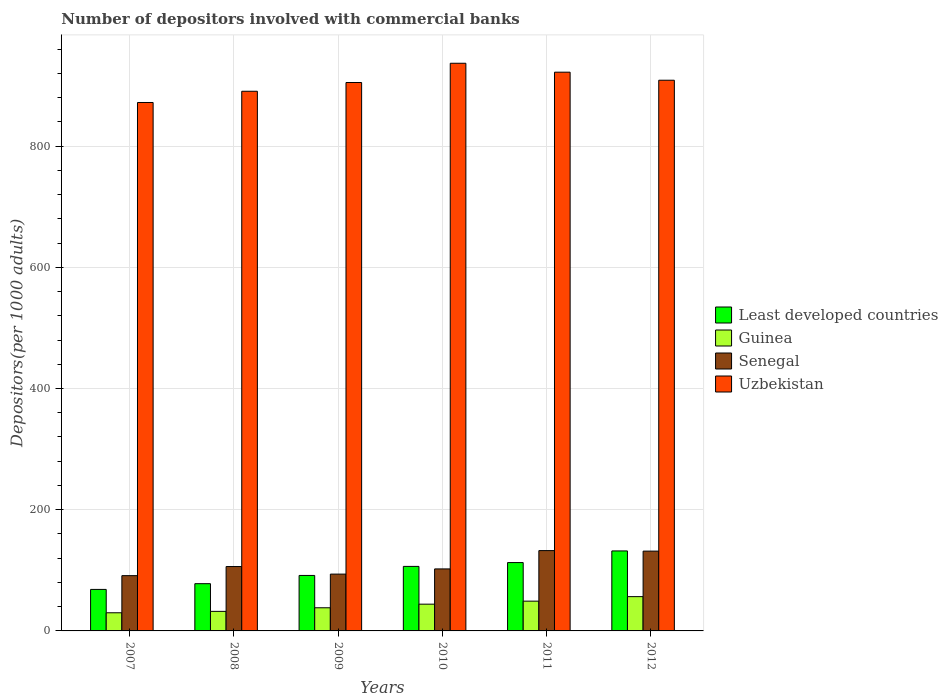How many groups of bars are there?
Provide a succinct answer. 6. Are the number of bars on each tick of the X-axis equal?
Your answer should be compact. Yes. How many bars are there on the 6th tick from the left?
Your response must be concise. 4. How many bars are there on the 2nd tick from the right?
Give a very brief answer. 4. What is the label of the 1st group of bars from the left?
Offer a terse response. 2007. What is the number of depositors involved with commercial banks in Senegal in 2009?
Offer a very short reply. 93.77. Across all years, what is the maximum number of depositors involved with commercial banks in Least developed countries?
Provide a short and direct response. 131.99. Across all years, what is the minimum number of depositors involved with commercial banks in Least developed countries?
Offer a terse response. 68.48. In which year was the number of depositors involved with commercial banks in Senegal minimum?
Provide a short and direct response. 2007. What is the total number of depositors involved with commercial banks in Guinea in the graph?
Your answer should be very brief. 250.28. What is the difference between the number of depositors involved with commercial banks in Senegal in 2010 and that in 2012?
Your answer should be compact. -29.37. What is the difference between the number of depositors involved with commercial banks in Least developed countries in 2008 and the number of depositors involved with commercial banks in Senegal in 2012?
Your answer should be very brief. -53.74. What is the average number of depositors involved with commercial banks in Least developed countries per year?
Your answer should be very brief. 98.21. In the year 2010, what is the difference between the number of depositors involved with commercial banks in Uzbekistan and number of depositors involved with commercial banks in Least developed countries?
Make the answer very short. 830.24. In how many years, is the number of depositors involved with commercial banks in Senegal greater than 680?
Offer a very short reply. 0. What is the ratio of the number of depositors involved with commercial banks in Senegal in 2009 to that in 2010?
Keep it short and to the point. 0.92. What is the difference between the highest and the second highest number of depositors involved with commercial banks in Senegal?
Your answer should be very brief. 0.84. What is the difference between the highest and the lowest number of depositors involved with commercial banks in Senegal?
Keep it short and to the point. 41.33. In how many years, is the number of depositors involved with commercial banks in Senegal greater than the average number of depositors involved with commercial banks in Senegal taken over all years?
Give a very brief answer. 2. Is it the case that in every year, the sum of the number of depositors involved with commercial banks in Guinea and number of depositors involved with commercial banks in Least developed countries is greater than the sum of number of depositors involved with commercial banks in Senegal and number of depositors involved with commercial banks in Uzbekistan?
Your response must be concise. No. What does the 4th bar from the left in 2009 represents?
Offer a very short reply. Uzbekistan. What does the 4th bar from the right in 2010 represents?
Make the answer very short. Least developed countries. Is it the case that in every year, the sum of the number of depositors involved with commercial banks in Least developed countries and number of depositors involved with commercial banks in Senegal is greater than the number of depositors involved with commercial banks in Guinea?
Provide a short and direct response. Yes. How many years are there in the graph?
Ensure brevity in your answer.  6. Are the values on the major ticks of Y-axis written in scientific E-notation?
Your answer should be very brief. No. Does the graph contain grids?
Keep it short and to the point. Yes. Where does the legend appear in the graph?
Provide a succinct answer. Center right. What is the title of the graph?
Provide a succinct answer. Number of depositors involved with commercial banks. Does "Ireland" appear as one of the legend labels in the graph?
Your response must be concise. No. What is the label or title of the X-axis?
Provide a succinct answer. Years. What is the label or title of the Y-axis?
Provide a succinct answer. Depositors(per 1000 adults). What is the Depositors(per 1000 adults) in Least developed countries in 2007?
Offer a terse response. 68.48. What is the Depositors(per 1000 adults) in Guinea in 2007?
Offer a terse response. 29.95. What is the Depositors(per 1000 adults) in Senegal in 2007?
Offer a very short reply. 91.2. What is the Depositors(per 1000 adults) of Uzbekistan in 2007?
Your response must be concise. 871.99. What is the Depositors(per 1000 adults) of Least developed countries in 2008?
Provide a short and direct response. 77.95. What is the Depositors(per 1000 adults) of Guinea in 2008?
Your response must be concise. 32.26. What is the Depositors(per 1000 adults) of Senegal in 2008?
Your answer should be compact. 106.25. What is the Depositors(per 1000 adults) of Uzbekistan in 2008?
Make the answer very short. 890.51. What is the Depositors(per 1000 adults) of Least developed countries in 2009?
Provide a succinct answer. 91.54. What is the Depositors(per 1000 adults) of Guinea in 2009?
Provide a succinct answer. 38.21. What is the Depositors(per 1000 adults) of Senegal in 2009?
Offer a very short reply. 93.77. What is the Depositors(per 1000 adults) in Uzbekistan in 2009?
Offer a terse response. 904.94. What is the Depositors(per 1000 adults) of Least developed countries in 2010?
Your response must be concise. 106.48. What is the Depositors(per 1000 adults) in Guinea in 2010?
Provide a short and direct response. 44.16. What is the Depositors(per 1000 adults) of Senegal in 2010?
Provide a short and direct response. 102.32. What is the Depositors(per 1000 adults) in Uzbekistan in 2010?
Your answer should be compact. 936.72. What is the Depositors(per 1000 adults) of Least developed countries in 2011?
Offer a terse response. 112.8. What is the Depositors(per 1000 adults) in Guinea in 2011?
Your response must be concise. 49.12. What is the Depositors(per 1000 adults) in Senegal in 2011?
Your answer should be very brief. 132.54. What is the Depositors(per 1000 adults) of Uzbekistan in 2011?
Your answer should be very brief. 921.99. What is the Depositors(per 1000 adults) of Least developed countries in 2012?
Keep it short and to the point. 131.99. What is the Depositors(per 1000 adults) of Guinea in 2012?
Your answer should be very brief. 56.59. What is the Depositors(per 1000 adults) of Senegal in 2012?
Your answer should be very brief. 131.69. What is the Depositors(per 1000 adults) in Uzbekistan in 2012?
Make the answer very short. 908.73. Across all years, what is the maximum Depositors(per 1000 adults) in Least developed countries?
Keep it short and to the point. 131.99. Across all years, what is the maximum Depositors(per 1000 adults) of Guinea?
Provide a succinct answer. 56.59. Across all years, what is the maximum Depositors(per 1000 adults) of Senegal?
Ensure brevity in your answer.  132.54. Across all years, what is the maximum Depositors(per 1000 adults) in Uzbekistan?
Your answer should be very brief. 936.72. Across all years, what is the minimum Depositors(per 1000 adults) of Least developed countries?
Provide a succinct answer. 68.48. Across all years, what is the minimum Depositors(per 1000 adults) in Guinea?
Provide a short and direct response. 29.95. Across all years, what is the minimum Depositors(per 1000 adults) in Senegal?
Make the answer very short. 91.2. Across all years, what is the minimum Depositors(per 1000 adults) of Uzbekistan?
Offer a very short reply. 871.99. What is the total Depositors(per 1000 adults) of Least developed countries in the graph?
Provide a short and direct response. 589.24. What is the total Depositors(per 1000 adults) of Guinea in the graph?
Your answer should be compact. 250.28. What is the total Depositors(per 1000 adults) in Senegal in the graph?
Provide a short and direct response. 657.78. What is the total Depositors(per 1000 adults) in Uzbekistan in the graph?
Give a very brief answer. 5434.87. What is the difference between the Depositors(per 1000 adults) in Least developed countries in 2007 and that in 2008?
Make the answer very short. -9.47. What is the difference between the Depositors(per 1000 adults) of Guinea in 2007 and that in 2008?
Keep it short and to the point. -2.31. What is the difference between the Depositors(per 1000 adults) in Senegal in 2007 and that in 2008?
Offer a terse response. -15.04. What is the difference between the Depositors(per 1000 adults) of Uzbekistan in 2007 and that in 2008?
Give a very brief answer. -18.52. What is the difference between the Depositors(per 1000 adults) in Least developed countries in 2007 and that in 2009?
Your answer should be very brief. -23.06. What is the difference between the Depositors(per 1000 adults) in Guinea in 2007 and that in 2009?
Provide a succinct answer. -8.26. What is the difference between the Depositors(per 1000 adults) in Senegal in 2007 and that in 2009?
Keep it short and to the point. -2.56. What is the difference between the Depositors(per 1000 adults) in Uzbekistan in 2007 and that in 2009?
Give a very brief answer. -32.96. What is the difference between the Depositors(per 1000 adults) of Least developed countries in 2007 and that in 2010?
Provide a succinct answer. -38. What is the difference between the Depositors(per 1000 adults) in Guinea in 2007 and that in 2010?
Make the answer very short. -14.21. What is the difference between the Depositors(per 1000 adults) in Senegal in 2007 and that in 2010?
Give a very brief answer. -11.12. What is the difference between the Depositors(per 1000 adults) of Uzbekistan in 2007 and that in 2010?
Ensure brevity in your answer.  -64.73. What is the difference between the Depositors(per 1000 adults) in Least developed countries in 2007 and that in 2011?
Keep it short and to the point. -44.32. What is the difference between the Depositors(per 1000 adults) of Guinea in 2007 and that in 2011?
Offer a very short reply. -19.18. What is the difference between the Depositors(per 1000 adults) in Senegal in 2007 and that in 2011?
Provide a succinct answer. -41.33. What is the difference between the Depositors(per 1000 adults) in Uzbekistan in 2007 and that in 2011?
Your response must be concise. -50. What is the difference between the Depositors(per 1000 adults) of Least developed countries in 2007 and that in 2012?
Offer a very short reply. -63.51. What is the difference between the Depositors(per 1000 adults) of Guinea in 2007 and that in 2012?
Keep it short and to the point. -26.64. What is the difference between the Depositors(per 1000 adults) of Senegal in 2007 and that in 2012?
Your response must be concise. -40.49. What is the difference between the Depositors(per 1000 adults) in Uzbekistan in 2007 and that in 2012?
Ensure brevity in your answer.  -36.74. What is the difference between the Depositors(per 1000 adults) of Least developed countries in 2008 and that in 2009?
Your answer should be compact. -13.59. What is the difference between the Depositors(per 1000 adults) of Guinea in 2008 and that in 2009?
Make the answer very short. -5.95. What is the difference between the Depositors(per 1000 adults) in Senegal in 2008 and that in 2009?
Keep it short and to the point. 12.48. What is the difference between the Depositors(per 1000 adults) in Uzbekistan in 2008 and that in 2009?
Keep it short and to the point. -14.44. What is the difference between the Depositors(per 1000 adults) in Least developed countries in 2008 and that in 2010?
Offer a terse response. -28.53. What is the difference between the Depositors(per 1000 adults) of Guinea in 2008 and that in 2010?
Make the answer very short. -11.9. What is the difference between the Depositors(per 1000 adults) of Senegal in 2008 and that in 2010?
Offer a very short reply. 3.92. What is the difference between the Depositors(per 1000 adults) in Uzbekistan in 2008 and that in 2010?
Provide a succinct answer. -46.21. What is the difference between the Depositors(per 1000 adults) in Least developed countries in 2008 and that in 2011?
Ensure brevity in your answer.  -34.85. What is the difference between the Depositors(per 1000 adults) of Guinea in 2008 and that in 2011?
Give a very brief answer. -16.87. What is the difference between the Depositors(per 1000 adults) of Senegal in 2008 and that in 2011?
Offer a very short reply. -26.29. What is the difference between the Depositors(per 1000 adults) in Uzbekistan in 2008 and that in 2011?
Your response must be concise. -31.48. What is the difference between the Depositors(per 1000 adults) of Least developed countries in 2008 and that in 2012?
Your answer should be very brief. -54.04. What is the difference between the Depositors(per 1000 adults) of Guinea in 2008 and that in 2012?
Give a very brief answer. -24.33. What is the difference between the Depositors(per 1000 adults) in Senegal in 2008 and that in 2012?
Your answer should be very brief. -25.45. What is the difference between the Depositors(per 1000 adults) in Uzbekistan in 2008 and that in 2012?
Keep it short and to the point. -18.22. What is the difference between the Depositors(per 1000 adults) of Least developed countries in 2009 and that in 2010?
Provide a short and direct response. -14.94. What is the difference between the Depositors(per 1000 adults) of Guinea in 2009 and that in 2010?
Provide a succinct answer. -5.95. What is the difference between the Depositors(per 1000 adults) of Senegal in 2009 and that in 2010?
Offer a terse response. -8.56. What is the difference between the Depositors(per 1000 adults) of Uzbekistan in 2009 and that in 2010?
Provide a short and direct response. -31.77. What is the difference between the Depositors(per 1000 adults) in Least developed countries in 2009 and that in 2011?
Make the answer very short. -21.26. What is the difference between the Depositors(per 1000 adults) in Guinea in 2009 and that in 2011?
Your answer should be very brief. -10.92. What is the difference between the Depositors(per 1000 adults) of Senegal in 2009 and that in 2011?
Your answer should be very brief. -38.77. What is the difference between the Depositors(per 1000 adults) of Uzbekistan in 2009 and that in 2011?
Keep it short and to the point. -17.04. What is the difference between the Depositors(per 1000 adults) in Least developed countries in 2009 and that in 2012?
Make the answer very short. -40.44. What is the difference between the Depositors(per 1000 adults) in Guinea in 2009 and that in 2012?
Your answer should be very brief. -18.38. What is the difference between the Depositors(per 1000 adults) in Senegal in 2009 and that in 2012?
Your answer should be compact. -37.92. What is the difference between the Depositors(per 1000 adults) of Uzbekistan in 2009 and that in 2012?
Your response must be concise. -3.78. What is the difference between the Depositors(per 1000 adults) in Least developed countries in 2010 and that in 2011?
Provide a succinct answer. -6.32. What is the difference between the Depositors(per 1000 adults) of Guinea in 2010 and that in 2011?
Give a very brief answer. -4.97. What is the difference between the Depositors(per 1000 adults) of Senegal in 2010 and that in 2011?
Keep it short and to the point. -30.21. What is the difference between the Depositors(per 1000 adults) in Uzbekistan in 2010 and that in 2011?
Your response must be concise. 14.73. What is the difference between the Depositors(per 1000 adults) of Least developed countries in 2010 and that in 2012?
Provide a succinct answer. -25.51. What is the difference between the Depositors(per 1000 adults) in Guinea in 2010 and that in 2012?
Your answer should be very brief. -12.44. What is the difference between the Depositors(per 1000 adults) in Senegal in 2010 and that in 2012?
Your answer should be very brief. -29.37. What is the difference between the Depositors(per 1000 adults) in Uzbekistan in 2010 and that in 2012?
Ensure brevity in your answer.  27.99. What is the difference between the Depositors(per 1000 adults) in Least developed countries in 2011 and that in 2012?
Offer a terse response. -19.19. What is the difference between the Depositors(per 1000 adults) in Guinea in 2011 and that in 2012?
Your answer should be very brief. -7.47. What is the difference between the Depositors(per 1000 adults) in Senegal in 2011 and that in 2012?
Your response must be concise. 0.84. What is the difference between the Depositors(per 1000 adults) in Uzbekistan in 2011 and that in 2012?
Your answer should be compact. 13.26. What is the difference between the Depositors(per 1000 adults) in Least developed countries in 2007 and the Depositors(per 1000 adults) in Guinea in 2008?
Offer a terse response. 36.22. What is the difference between the Depositors(per 1000 adults) of Least developed countries in 2007 and the Depositors(per 1000 adults) of Senegal in 2008?
Your answer should be very brief. -37.77. What is the difference between the Depositors(per 1000 adults) of Least developed countries in 2007 and the Depositors(per 1000 adults) of Uzbekistan in 2008?
Your answer should be compact. -822.02. What is the difference between the Depositors(per 1000 adults) in Guinea in 2007 and the Depositors(per 1000 adults) in Senegal in 2008?
Keep it short and to the point. -76.3. What is the difference between the Depositors(per 1000 adults) in Guinea in 2007 and the Depositors(per 1000 adults) in Uzbekistan in 2008?
Your response must be concise. -860.56. What is the difference between the Depositors(per 1000 adults) of Senegal in 2007 and the Depositors(per 1000 adults) of Uzbekistan in 2008?
Offer a terse response. -799.3. What is the difference between the Depositors(per 1000 adults) in Least developed countries in 2007 and the Depositors(per 1000 adults) in Guinea in 2009?
Offer a very short reply. 30.27. What is the difference between the Depositors(per 1000 adults) of Least developed countries in 2007 and the Depositors(per 1000 adults) of Senegal in 2009?
Keep it short and to the point. -25.29. What is the difference between the Depositors(per 1000 adults) of Least developed countries in 2007 and the Depositors(per 1000 adults) of Uzbekistan in 2009?
Offer a very short reply. -836.46. What is the difference between the Depositors(per 1000 adults) in Guinea in 2007 and the Depositors(per 1000 adults) in Senegal in 2009?
Keep it short and to the point. -63.82. What is the difference between the Depositors(per 1000 adults) of Guinea in 2007 and the Depositors(per 1000 adults) of Uzbekistan in 2009?
Provide a succinct answer. -875. What is the difference between the Depositors(per 1000 adults) in Senegal in 2007 and the Depositors(per 1000 adults) in Uzbekistan in 2009?
Provide a succinct answer. -813.74. What is the difference between the Depositors(per 1000 adults) of Least developed countries in 2007 and the Depositors(per 1000 adults) of Guinea in 2010?
Offer a very short reply. 24.33. What is the difference between the Depositors(per 1000 adults) in Least developed countries in 2007 and the Depositors(per 1000 adults) in Senegal in 2010?
Your answer should be compact. -33.84. What is the difference between the Depositors(per 1000 adults) in Least developed countries in 2007 and the Depositors(per 1000 adults) in Uzbekistan in 2010?
Provide a succinct answer. -868.24. What is the difference between the Depositors(per 1000 adults) in Guinea in 2007 and the Depositors(per 1000 adults) in Senegal in 2010?
Keep it short and to the point. -72.38. What is the difference between the Depositors(per 1000 adults) of Guinea in 2007 and the Depositors(per 1000 adults) of Uzbekistan in 2010?
Provide a short and direct response. -906.77. What is the difference between the Depositors(per 1000 adults) of Senegal in 2007 and the Depositors(per 1000 adults) of Uzbekistan in 2010?
Offer a very short reply. -845.51. What is the difference between the Depositors(per 1000 adults) of Least developed countries in 2007 and the Depositors(per 1000 adults) of Guinea in 2011?
Your answer should be very brief. 19.36. What is the difference between the Depositors(per 1000 adults) of Least developed countries in 2007 and the Depositors(per 1000 adults) of Senegal in 2011?
Offer a very short reply. -64.06. What is the difference between the Depositors(per 1000 adults) of Least developed countries in 2007 and the Depositors(per 1000 adults) of Uzbekistan in 2011?
Offer a very short reply. -853.51. What is the difference between the Depositors(per 1000 adults) of Guinea in 2007 and the Depositors(per 1000 adults) of Senegal in 2011?
Offer a terse response. -102.59. What is the difference between the Depositors(per 1000 adults) in Guinea in 2007 and the Depositors(per 1000 adults) in Uzbekistan in 2011?
Give a very brief answer. -892.04. What is the difference between the Depositors(per 1000 adults) of Senegal in 2007 and the Depositors(per 1000 adults) of Uzbekistan in 2011?
Your answer should be compact. -830.78. What is the difference between the Depositors(per 1000 adults) of Least developed countries in 2007 and the Depositors(per 1000 adults) of Guinea in 2012?
Your answer should be compact. 11.89. What is the difference between the Depositors(per 1000 adults) in Least developed countries in 2007 and the Depositors(per 1000 adults) in Senegal in 2012?
Make the answer very short. -63.21. What is the difference between the Depositors(per 1000 adults) of Least developed countries in 2007 and the Depositors(per 1000 adults) of Uzbekistan in 2012?
Provide a succinct answer. -840.25. What is the difference between the Depositors(per 1000 adults) in Guinea in 2007 and the Depositors(per 1000 adults) in Senegal in 2012?
Provide a short and direct response. -101.75. What is the difference between the Depositors(per 1000 adults) in Guinea in 2007 and the Depositors(per 1000 adults) in Uzbekistan in 2012?
Provide a succinct answer. -878.78. What is the difference between the Depositors(per 1000 adults) of Senegal in 2007 and the Depositors(per 1000 adults) of Uzbekistan in 2012?
Offer a terse response. -817.52. What is the difference between the Depositors(per 1000 adults) in Least developed countries in 2008 and the Depositors(per 1000 adults) in Guinea in 2009?
Provide a succinct answer. 39.74. What is the difference between the Depositors(per 1000 adults) in Least developed countries in 2008 and the Depositors(per 1000 adults) in Senegal in 2009?
Keep it short and to the point. -15.82. What is the difference between the Depositors(per 1000 adults) in Least developed countries in 2008 and the Depositors(per 1000 adults) in Uzbekistan in 2009?
Ensure brevity in your answer.  -826.99. What is the difference between the Depositors(per 1000 adults) in Guinea in 2008 and the Depositors(per 1000 adults) in Senegal in 2009?
Ensure brevity in your answer.  -61.51. What is the difference between the Depositors(per 1000 adults) in Guinea in 2008 and the Depositors(per 1000 adults) in Uzbekistan in 2009?
Your response must be concise. -872.69. What is the difference between the Depositors(per 1000 adults) in Senegal in 2008 and the Depositors(per 1000 adults) in Uzbekistan in 2009?
Give a very brief answer. -798.7. What is the difference between the Depositors(per 1000 adults) in Least developed countries in 2008 and the Depositors(per 1000 adults) in Guinea in 2010?
Provide a short and direct response. 33.8. What is the difference between the Depositors(per 1000 adults) in Least developed countries in 2008 and the Depositors(per 1000 adults) in Senegal in 2010?
Your response must be concise. -24.37. What is the difference between the Depositors(per 1000 adults) in Least developed countries in 2008 and the Depositors(per 1000 adults) in Uzbekistan in 2010?
Your response must be concise. -858.77. What is the difference between the Depositors(per 1000 adults) in Guinea in 2008 and the Depositors(per 1000 adults) in Senegal in 2010?
Offer a very short reply. -70.07. What is the difference between the Depositors(per 1000 adults) in Guinea in 2008 and the Depositors(per 1000 adults) in Uzbekistan in 2010?
Ensure brevity in your answer.  -904.46. What is the difference between the Depositors(per 1000 adults) of Senegal in 2008 and the Depositors(per 1000 adults) of Uzbekistan in 2010?
Provide a short and direct response. -830.47. What is the difference between the Depositors(per 1000 adults) in Least developed countries in 2008 and the Depositors(per 1000 adults) in Guinea in 2011?
Provide a succinct answer. 28.83. What is the difference between the Depositors(per 1000 adults) in Least developed countries in 2008 and the Depositors(per 1000 adults) in Senegal in 2011?
Your response must be concise. -54.59. What is the difference between the Depositors(per 1000 adults) of Least developed countries in 2008 and the Depositors(per 1000 adults) of Uzbekistan in 2011?
Your response must be concise. -844.04. What is the difference between the Depositors(per 1000 adults) in Guinea in 2008 and the Depositors(per 1000 adults) in Senegal in 2011?
Offer a very short reply. -100.28. What is the difference between the Depositors(per 1000 adults) of Guinea in 2008 and the Depositors(per 1000 adults) of Uzbekistan in 2011?
Offer a terse response. -889.73. What is the difference between the Depositors(per 1000 adults) in Senegal in 2008 and the Depositors(per 1000 adults) in Uzbekistan in 2011?
Your answer should be very brief. -815.74. What is the difference between the Depositors(per 1000 adults) in Least developed countries in 2008 and the Depositors(per 1000 adults) in Guinea in 2012?
Provide a succinct answer. 21.36. What is the difference between the Depositors(per 1000 adults) of Least developed countries in 2008 and the Depositors(per 1000 adults) of Senegal in 2012?
Ensure brevity in your answer.  -53.74. What is the difference between the Depositors(per 1000 adults) in Least developed countries in 2008 and the Depositors(per 1000 adults) in Uzbekistan in 2012?
Provide a short and direct response. -830.78. What is the difference between the Depositors(per 1000 adults) of Guinea in 2008 and the Depositors(per 1000 adults) of Senegal in 2012?
Make the answer very short. -99.44. What is the difference between the Depositors(per 1000 adults) in Guinea in 2008 and the Depositors(per 1000 adults) in Uzbekistan in 2012?
Offer a terse response. -876.47. What is the difference between the Depositors(per 1000 adults) of Senegal in 2008 and the Depositors(per 1000 adults) of Uzbekistan in 2012?
Offer a very short reply. -802.48. What is the difference between the Depositors(per 1000 adults) of Least developed countries in 2009 and the Depositors(per 1000 adults) of Guinea in 2010?
Ensure brevity in your answer.  47.39. What is the difference between the Depositors(per 1000 adults) in Least developed countries in 2009 and the Depositors(per 1000 adults) in Senegal in 2010?
Keep it short and to the point. -10.78. What is the difference between the Depositors(per 1000 adults) in Least developed countries in 2009 and the Depositors(per 1000 adults) in Uzbekistan in 2010?
Your answer should be compact. -845.17. What is the difference between the Depositors(per 1000 adults) in Guinea in 2009 and the Depositors(per 1000 adults) in Senegal in 2010?
Provide a succinct answer. -64.12. What is the difference between the Depositors(per 1000 adults) in Guinea in 2009 and the Depositors(per 1000 adults) in Uzbekistan in 2010?
Your answer should be compact. -898.51. What is the difference between the Depositors(per 1000 adults) of Senegal in 2009 and the Depositors(per 1000 adults) of Uzbekistan in 2010?
Keep it short and to the point. -842.95. What is the difference between the Depositors(per 1000 adults) in Least developed countries in 2009 and the Depositors(per 1000 adults) in Guinea in 2011?
Your answer should be compact. 42.42. What is the difference between the Depositors(per 1000 adults) of Least developed countries in 2009 and the Depositors(per 1000 adults) of Senegal in 2011?
Your response must be concise. -40.99. What is the difference between the Depositors(per 1000 adults) of Least developed countries in 2009 and the Depositors(per 1000 adults) of Uzbekistan in 2011?
Your response must be concise. -830.44. What is the difference between the Depositors(per 1000 adults) of Guinea in 2009 and the Depositors(per 1000 adults) of Senegal in 2011?
Give a very brief answer. -94.33. What is the difference between the Depositors(per 1000 adults) in Guinea in 2009 and the Depositors(per 1000 adults) in Uzbekistan in 2011?
Offer a terse response. -883.78. What is the difference between the Depositors(per 1000 adults) of Senegal in 2009 and the Depositors(per 1000 adults) of Uzbekistan in 2011?
Your answer should be compact. -828.22. What is the difference between the Depositors(per 1000 adults) in Least developed countries in 2009 and the Depositors(per 1000 adults) in Guinea in 2012?
Provide a short and direct response. 34.95. What is the difference between the Depositors(per 1000 adults) in Least developed countries in 2009 and the Depositors(per 1000 adults) in Senegal in 2012?
Offer a very short reply. -40.15. What is the difference between the Depositors(per 1000 adults) in Least developed countries in 2009 and the Depositors(per 1000 adults) in Uzbekistan in 2012?
Provide a short and direct response. -817.18. What is the difference between the Depositors(per 1000 adults) of Guinea in 2009 and the Depositors(per 1000 adults) of Senegal in 2012?
Keep it short and to the point. -93.49. What is the difference between the Depositors(per 1000 adults) in Guinea in 2009 and the Depositors(per 1000 adults) in Uzbekistan in 2012?
Provide a succinct answer. -870.52. What is the difference between the Depositors(per 1000 adults) in Senegal in 2009 and the Depositors(per 1000 adults) in Uzbekistan in 2012?
Provide a succinct answer. -814.96. What is the difference between the Depositors(per 1000 adults) of Least developed countries in 2010 and the Depositors(per 1000 adults) of Guinea in 2011?
Provide a short and direct response. 57.36. What is the difference between the Depositors(per 1000 adults) of Least developed countries in 2010 and the Depositors(per 1000 adults) of Senegal in 2011?
Ensure brevity in your answer.  -26.05. What is the difference between the Depositors(per 1000 adults) of Least developed countries in 2010 and the Depositors(per 1000 adults) of Uzbekistan in 2011?
Give a very brief answer. -815.51. What is the difference between the Depositors(per 1000 adults) of Guinea in 2010 and the Depositors(per 1000 adults) of Senegal in 2011?
Keep it short and to the point. -88.38. What is the difference between the Depositors(per 1000 adults) of Guinea in 2010 and the Depositors(per 1000 adults) of Uzbekistan in 2011?
Offer a very short reply. -877.83. What is the difference between the Depositors(per 1000 adults) of Senegal in 2010 and the Depositors(per 1000 adults) of Uzbekistan in 2011?
Your answer should be very brief. -819.66. What is the difference between the Depositors(per 1000 adults) in Least developed countries in 2010 and the Depositors(per 1000 adults) in Guinea in 2012?
Provide a succinct answer. 49.89. What is the difference between the Depositors(per 1000 adults) in Least developed countries in 2010 and the Depositors(per 1000 adults) in Senegal in 2012?
Offer a very short reply. -25.21. What is the difference between the Depositors(per 1000 adults) of Least developed countries in 2010 and the Depositors(per 1000 adults) of Uzbekistan in 2012?
Your response must be concise. -802.25. What is the difference between the Depositors(per 1000 adults) of Guinea in 2010 and the Depositors(per 1000 adults) of Senegal in 2012?
Your answer should be very brief. -87.54. What is the difference between the Depositors(per 1000 adults) in Guinea in 2010 and the Depositors(per 1000 adults) in Uzbekistan in 2012?
Make the answer very short. -864.57. What is the difference between the Depositors(per 1000 adults) of Senegal in 2010 and the Depositors(per 1000 adults) of Uzbekistan in 2012?
Keep it short and to the point. -806.4. What is the difference between the Depositors(per 1000 adults) in Least developed countries in 2011 and the Depositors(per 1000 adults) in Guinea in 2012?
Offer a very short reply. 56.21. What is the difference between the Depositors(per 1000 adults) in Least developed countries in 2011 and the Depositors(per 1000 adults) in Senegal in 2012?
Give a very brief answer. -18.89. What is the difference between the Depositors(per 1000 adults) of Least developed countries in 2011 and the Depositors(per 1000 adults) of Uzbekistan in 2012?
Your answer should be very brief. -795.93. What is the difference between the Depositors(per 1000 adults) in Guinea in 2011 and the Depositors(per 1000 adults) in Senegal in 2012?
Ensure brevity in your answer.  -82.57. What is the difference between the Depositors(per 1000 adults) in Guinea in 2011 and the Depositors(per 1000 adults) in Uzbekistan in 2012?
Your response must be concise. -859.6. What is the difference between the Depositors(per 1000 adults) of Senegal in 2011 and the Depositors(per 1000 adults) of Uzbekistan in 2012?
Keep it short and to the point. -776.19. What is the average Depositors(per 1000 adults) in Least developed countries per year?
Keep it short and to the point. 98.21. What is the average Depositors(per 1000 adults) of Guinea per year?
Offer a very short reply. 41.71. What is the average Depositors(per 1000 adults) of Senegal per year?
Keep it short and to the point. 109.63. What is the average Depositors(per 1000 adults) in Uzbekistan per year?
Your response must be concise. 905.81. In the year 2007, what is the difference between the Depositors(per 1000 adults) in Least developed countries and Depositors(per 1000 adults) in Guinea?
Offer a very short reply. 38.54. In the year 2007, what is the difference between the Depositors(per 1000 adults) of Least developed countries and Depositors(per 1000 adults) of Senegal?
Give a very brief answer. -22.72. In the year 2007, what is the difference between the Depositors(per 1000 adults) in Least developed countries and Depositors(per 1000 adults) in Uzbekistan?
Keep it short and to the point. -803.51. In the year 2007, what is the difference between the Depositors(per 1000 adults) in Guinea and Depositors(per 1000 adults) in Senegal?
Ensure brevity in your answer.  -61.26. In the year 2007, what is the difference between the Depositors(per 1000 adults) of Guinea and Depositors(per 1000 adults) of Uzbekistan?
Provide a succinct answer. -842.04. In the year 2007, what is the difference between the Depositors(per 1000 adults) in Senegal and Depositors(per 1000 adults) in Uzbekistan?
Keep it short and to the point. -780.78. In the year 2008, what is the difference between the Depositors(per 1000 adults) of Least developed countries and Depositors(per 1000 adults) of Guinea?
Your response must be concise. 45.7. In the year 2008, what is the difference between the Depositors(per 1000 adults) in Least developed countries and Depositors(per 1000 adults) in Senegal?
Give a very brief answer. -28.3. In the year 2008, what is the difference between the Depositors(per 1000 adults) in Least developed countries and Depositors(per 1000 adults) in Uzbekistan?
Offer a very short reply. -812.55. In the year 2008, what is the difference between the Depositors(per 1000 adults) in Guinea and Depositors(per 1000 adults) in Senegal?
Make the answer very short. -73.99. In the year 2008, what is the difference between the Depositors(per 1000 adults) in Guinea and Depositors(per 1000 adults) in Uzbekistan?
Your response must be concise. -858.25. In the year 2008, what is the difference between the Depositors(per 1000 adults) in Senegal and Depositors(per 1000 adults) in Uzbekistan?
Provide a short and direct response. -784.26. In the year 2009, what is the difference between the Depositors(per 1000 adults) of Least developed countries and Depositors(per 1000 adults) of Guinea?
Ensure brevity in your answer.  53.33. In the year 2009, what is the difference between the Depositors(per 1000 adults) in Least developed countries and Depositors(per 1000 adults) in Senegal?
Your answer should be compact. -2.23. In the year 2009, what is the difference between the Depositors(per 1000 adults) in Least developed countries and Depositors(per 1000 adults) in Uzbekistan?
Provide a short and direct response. -813.4. In the year 2009, what is the difference between the Depositors(per 1000 adults) of Guinea and Depositors(per 1000 adults) of Senegal?
Your answer should be compact. -55.56. In the year 2009, what is the difference between the Depositors(per 1000 adults) in Guinea and Depositors(per 1000 adults) in Uzbekistan?
Offer a terse response. -866.73. In the year 2009, what is the difference between the Depositors(per 1000 adults) of Senegal and Depositors(per 1000 adults) of Uzbekistan?
Give a very brief answer. -811.17. In the year 2010, what is the difference between the Depositors(per 1000 adults) of Least developed countries and Depositors(per 1000 adults) of Guinea?
Offer a terse response. 62.33. In the year 2010, what is the difference between the Depositors(per 1000 adults) of Least developed countries and Depositors(per 1000 adults) of Senegal?
Offer a very short reply. 4.16. In the year 2010, what is the difference between the Depositors(per 1000 adults) in Least developed countries and Depositors(per 1000 adults) in Uzbekistan?
Your answer should be very brief. -830.24. In the year 2010, what is the difference between the Depositors(per 1000 adults) of Guinea and Depositors(per 1000 adults) of Senegal?
Keep it short and to the point. -58.17. In the year 2010, what is the difference between the Depositors(per 1000 adults) of Guinea and Depositors(per 1000 adults) of Uzbekistan?
Your answer should be compact. -892.56. In the year 2010, what is the difference between the Depositors(per 1000 adults) of Senegal and Depositors(per 1000 adults) of Uzbekistan?
Offer a terse response. -834.39. In the year 2011, what is the difference between the Depositors(per 1000 adults) of Least developed countries and Depositors(per 1000 adults) of Guinea?
Your answer should be compact. 63.68. In the year 2011, what is the difference between the Depositors(per 1000 adults) in Least developed countries and Depositors(per 1000 adults) in Senegal?
Give a very brief answer. -19.74. In the year 2011, what is the difference between the Depositors(per 1000 adults) in Least developed countries and Depositors(per 1000 adults) in Uzbekistan?
Provide a short and direct response. -809.19. In the year 2011, what is the difference between the Depositors(per 1000 adults) in Guinea and Depositors(per 1000 adults) in Senegal?
Keep it short and to the point. -83.41. In the year 2011, what is the difference between the Depositors(per 1000 adults) of Guinea and Depositors(per 1000 adults) of Uzbekistan?
Make the answer very short. -872.86. In the year 2011, what is the difference between the Depositors(per 1000 adults) of Senegal and Depositors(per 1000 adults) of Uzbekistan?
Ensure brevity in your answer.  -789.45. In the year 2012, what is the difference between the Depositors(per 1000 adults) of Least developed countries and Depositors(per 1000 adults) of Guinea?
Your answer should be very brief. 75.4. In the year 2012, what is the difference between the Depositors(per 1000 adults) in Least developed countries and Depositors(per 1000 adults) in Senegal?
Ensure brevity in your answer.  0.29. In the year 2012, what is the difference between the Depositors(per 1000 adults) in Least developed countries and Depositors(per 1000 adults) in Uzbekistan?
Offer a very short reply. -776.74. In the year 2012, what is the difference between the Depositors(per 1000 adults) of Guinea and Depositors(per 1000 adults) of Senegal?
Make the answer very short. -75.1. In the year 2012, what is the difference between the Depositors(per 1000 adults) in Guinea and Depositors(per 1000 adults) in Uzbekistan?
Ensure brevity in your answer.  -852.14. In the year 2012, what is the difference between the Depositors(per 1000 adults) in Senegal and Depositors(per 1000 adults) in Uzbekistan?
Your answer should be very brief. -777.03. What is the ratio of the Depositors(per 1000 adults) of Least developed countries in 2007 to that in 2008?
Give a very brief answer. 0.88. What is the ratio of the Depositors(per 1000 adults) of Guinea in 2007 to that in 2008?
Give a very brief answer. 0.93. What is the ratio of the Depositors(per 1000 adults) in Senegal in 2007 to that in 2008?
Give a very brief answer. 0.86. What is the ratio of the Depositors(per 1000 adults) of Uzbekistan in 2007 to that in 2008?
Your response must be concise. 0.98. What is the ratio of the Depositors(per 1000 adults) of Least developed countries in 2007 to that in 2009?
Provide a succinct answer. 0.75. What is the ratio of the Depositors(per 1000 adults) in Guinea in 2007 to that in 2009?
Give a very brief answer. 0.78. What is the ratio of the Depositors(per 1000 adults) in Senegal in 2007 to that in 2009?
Keep it short and to the point. 0.97. What is the ratio of the Depositors(per 1000 adults) in Uzbekistan in 2007 to that in 2009?
Keep it short and to the point. 0.96. What is the ratio of the Depositors(per 1000 adults) in Least developed countries in 2007 to that in 2010?
Offer a terse response. 0.64. What is the ratio of the Depositors(per 1000 adults) in Guinea in 2007 to that in 2010?
Your answer should be compact. 0.68. What is the ratio of the Depositors(per 1000 adults) in Senegal in 2007 to that in 2010?
Make the answer very short. 0.89. What is the ratio of the Depositors(per 1000 adults) of Uzbekistan in 2007 to that in 2010?
Keep it short and to the point. 0.93. What is the ratio of the Depositors(per 1000 adults) of Least developed countries in 2007 to that in 2011?
Offer a very short reply. 0.61. What is the ratio of the Depositors(per 1000 adults) of Guinea in 2007 to that in 2011?
Keep it short and to the point. 0.61. What is the ratio of the Depositors(per 1000 adults) in Senegal in 2007 to that in 2011?
Offer a very short reply. 0.69. What is the ratio of the Depositors(per 1000 adults) of Uzbekistan in 2007 to that in 2011?
Your response must be concise. 0.95. What is the ratio of the Depositors(per 1000 adults) in Least developed countries in 2007 to that in 2012?
Your response must be concise. 0.52. What is the ratio of the Depositors(per 1000 adults) in Guinea in 2007 to that in 2012?
Provide a succinct answer. 0.53. What is the ratio of the Depositors(per 1000 adults) in Senegal in 2007 to that in 2012?
Provide a short and direct response. 0.69. What is the ratio of the Depositors(per 1000 adults) in Uzbekistan in 2007 to that in 2012?
Make the answer very short. 0.96. What is the ratio of the Depositors(per 1000 adults) in Least developed countries in 2008 to that in 2009?
Ensure brevity in your answer.  0.85. What is the ratio of the Depositors(per 1000 adults) in Guinea in 2008 to that in 2009?
Ensure brevity in your answer.  0.84. What is the ratio of the Depositors(per 1000 adults) in Senegal in 2008 to that in 2009?
Offer a terse response. 1.13. What is the ratio of the Depositors(per 1000 adults) of Least developed countries in 2008 to that in 2010?
Ensure brevity in your answer.  0.73. What is the ratio of the Depositors(per 1000 adults) of Guinea in 2008 to that in 2010?
Your response must be concise. 0.73. What is the ratio of the Depositors(per 1000 adults) in Senegal in 2008 to that in 2010?
Offer a terse response. 1.04. What is the ratio of the Depositors(per 1000 adults) of Uzbekistan in 2008 to that in 2010?
Ensure brevity in your answer.  0.95. What is the ratio of the Depositors(per 1000 adults) in Least developed countries in 2008 to that in 2011?
Provide a short and direct response. 0.69. What is the ratio of the Depositors(per 1000 adults) of Guinea in 2008 to that in 2011?
Offer a very short reply. 0.66. What is the ratio of the Depositors(per 1000 adults) of Senegal in 2008 to that in 2011?
Your response must be concise. 0.8. What is the ratio of the Depositors(per 1000 adults) of Uzbekistan in 2008 to that in 2011?
Ensure brevity in your answer.  0.97. What is the ratio of the Depositors(per 1000 adults) of Least developed countries in 2008 to that in 2012?
Your answer should be very brief. 0.59. What is the ratio of the Depositors(per 1000 adults) of Guinea in 2008 to that in 2012?
Ensure brevity in your answer.  0.57. What is the ratio of the Depositors(per 1000 adults) of Senegal in 2008 to that in 2012?
Offer a very short reply. 0.81. What is the ratio of the Depositors(per 1000 adults) of Uzbekistan in 2008 to that in 2012?
Offer a terse response. 0.98. What is the ratio of the Depositors(per 1000 adults) in Least developed countries in 2009 to that in 2010?
Keep it short and to the point. 0.86. What is the ratio of the Depositors(per 1000 adults) of Guinea in 2009 to that in 2010?
Your response must be concise. 0.87. What is the ratio of the Depositors(per 1000 adults) in Senegal in 2009 to that in 2010?
Give a very brief answer. 0.92. What is the ratio of the Depositors(per 1000 adults) in Uzbekistan in 2009 to that in 2010?
Your answer should be compact. 0.97. What is the ratio of the Depositors(per 1000 adults) of Least developed countries in 2009 to that in 2011?
Provide a short and direct response. 0.81. What is the ratio of the Depositors(per 1000 adults) in Senegal in 2009 to that in 2011?
Your answer should be very brief. 0.71. What is the ratio of the Depositors(per 1000 adults) of Uzbekistan in 2009 to that in 2011?
Your answer should be compact. 0.98. What is the ratio of the Depositors(per 1000 adults) of Least developed countries in 2009 to that in 2012?
Keep it short and to the point. 0.69. What is the ratio of the Depositors(per 1000 adults) of Guinea in 2009 to that in 2012?
Your answer should be very brief. 0.68. What is the ratio of the Depositors(per 1000 adults) in Senegal in 2009 to that in 2012?
Offer a very short reply. 0.71. What is the ratio of the Depositors(per 1000 adults) in Least developed countries in 2010 to that in 2011?
Offer a terse response. 0.94. What is the ratio of the Depositors(per 1000 adults) of Guinea in 2010 to that in 2011?
Provide a succinct answer. 0.9. What is the ratio of the Depositors(per 1000 adults) in Senegal in 2010 to that in 2011?
Give a very brief answer. 0.77. What is the ratio of the Depositors(per 1000 adults) in Uzbekistan in 2010 to that in 2011?
Offer a very short reply. 1.02. What is the ratio of the Depositors(per 1000 adults) in Least developed countries in 2010 to that in 2012?
Your answer should be very brief. 0.81. What is the ratio of the Depositors(per 1000 adults) in Guinea in 2010 to that in 2012?
Make the answer very short. 0.78. What is the ratio of the Depositors(per 1000 adults) in Senegal in 2010 to that in 2012?
Offer a terse response. 0.78. What is the ratio of the Depositors(per 1000 adults) in Uzbekistan in 2010 to that in 2012?
Provide a succinct answer. 1.03. What is the ratio of the Depositors(per 1000 adults) in Least developed countries in 2011 to that in 2012?
Give a very brief answer. 0.85. What is the ratio of the Depositors(per 1000 adults) of Guinea in 2011 to that in 2012?
Your answer should be compact. 0.87. What is the ratio of the Depositors(per 1000 adults) in Senegal in 2011 to that in 2012?
Give a very brief answer. 1.01. What is the ratio of the Depositors(per 1000 adults) of Uzbekistan in 2011 to that in 2012?
Offer a very short reply. 1.01. What is the difference between the highest and the second highest Depositors(per 1000 adults) in Least developed countries?
Offer a terse response. 19.19. What is the difference between the highest and the second highest Depositors(per 1000 adults) in Guinea?
Your answer should be very brief. 7.47. What is the difference between the highest and the second highest Depositors(per 1000 adults) of Senegal?
Ensure brevity in your answer.  0.84. What is the difference between the highest and the second highest Depositors(per 1000 adults) in Uzbekistan?
Provide a succinct answer. 14.73. What is the difference between the highest and the lowest Depositors(per 1000 adults) of Least developed countries?
Your answer should be very brief. 63.51. What is the difference between the highest and the lowest Depositors(per 1000 adults) of Guinea?
Offer a very short reply. 26.64. What is the difference between the highest and the lowest Depositors(per 1000 adults) in Senegal?
Offer a very short reply. 41.33. What is the difference between the highest and the lowest Depositors(per 1000 adults) in Uzbekistan?
Give a very brief answer. 64.73. 